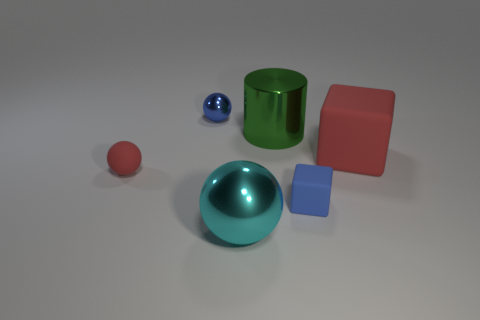How many cylinders are either red matte objects or small red objects?
Your response must be concise. 0. There is a ball that is the same color as the large block; what is its size?
Provide a succinct answer. Small. Are there fewer large objects that are left of the green metallic object than big brown matte balls?
Give a very brief answer. No. The metal object that is both behind the small block and on the right side of the small blue metal ball is what color?
Ensure brevity in your answer.  Green. What number of other objects are the same shape as the green shiny object?
Your answer should be very brief. 0. Is the number of large balls behind the big green object less than the number of tiny things that are right of the cyan ball?
Provide a short and direct response. Yes. Is the big cyan sphere made of the same material as the blue thing that is in front of the small blue metallic sphere?
Offer a very short reply. No. Is the number of big matte cubes greater than the number of tiny yellow metal cubes?
Your response must be concise. Yes. There is a small thing that is left of the thing that is behind the shiny thing on the right side of the big cyan shiny sphere; what is its shape?
Your response must be concise. Sphere. Do the large object in front of the big rubber cube and the sphere to the left of the blue metallic thing have the same material?
Ensure brevity in your answer.  No. 